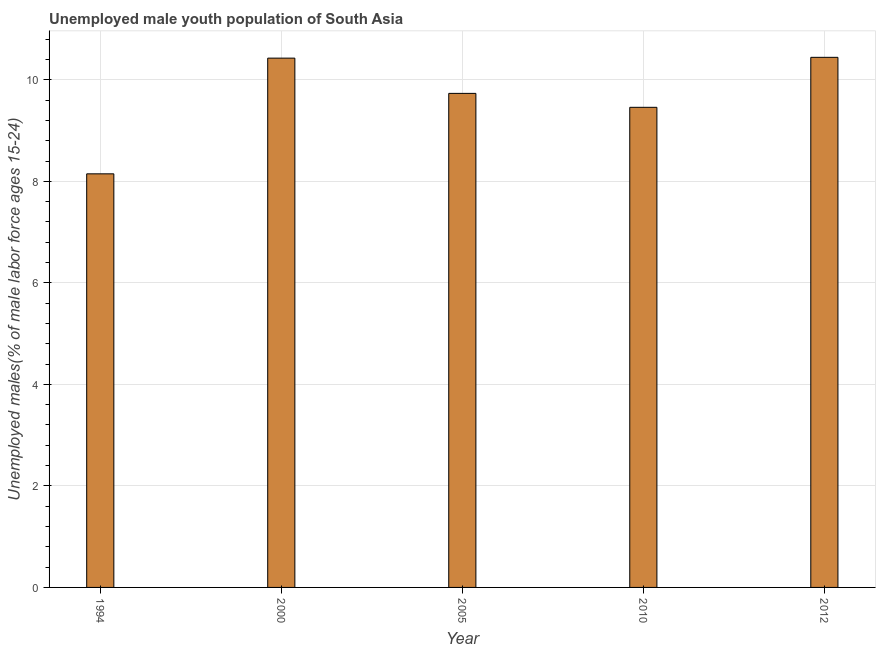Does the graph contain any zero values?
Your answer should be very brief. No. What is the title of the graph?
Your answer should be compact. Unemployed male youth population of South Asia. What is the label or title of the X-axis?
Your answer should be very brief. Year. What is the label or title of the Y-axis?
Your response must be concise. Unemployed males(% of male labor force ages 15-24). What is the unemployed male youth in 2010?
Provide a succinct answer. 9.46. Across all years, what is the maximum unemployed male youth?
Your answer should be compact. 10.44. Across all years, what is the minimum unemployed male youth?
Your answer should be very brief. 8.15. In which year was the unemployed male youth maximum?
Make the answer very short. 2012. In which year was the unemployed male youth minimum?
Ensure brevity in your answer.  1994. What is the sum of the unemployed male youth?
Your answer should be very brief. 48.21. What is the difference between the unemployed male youth in 2005 and 2010?
Make the answer very short. 0.28. What is the average unemployed male youth per year?
Give a very brief answer. 9.64. What is the median unemployed male youth?
Your answer should be very brief. 9.73. In how many years, is the unemployed male youth greater than 8.8 %?
Ensure brevity in your answer.  4. What is the ratio of the unemployed male youth in 1994 to that in 2010?
Your response must be concise. 0.86. Is the unemployed male youth in 1994 less than that in 2000?
Your answer should be compact. Yes. Is the difference between the unemployed male youth in 1994 and 2000 greater than the difference between any two years?
Provide a short and direct response. No. What is the difference between the highest and the second highest unemployed male youth?
Your response must be concise. 0.02. Is the sum of the unemployed male youth in 2000 and 2005 greater than the maximum unemployed male youth across all years?
Provide a short and direct response. Yes. How many bars are there?
Your answer should be compact. 5. Are all the bars in the graph horizontal?
Provide a short and direct response. No. How many years are there in the graph?
Your answer should be very brief. 5. Are the values on the major ticks of Y-axis written in scientific E-notation?
Give a very brief answer. No. What is the Unemployed males(% of male labor force ages 15-24) of 1994?
Give a very brief answer. 8.15. What is the Unemployed males(% of male labor force ages 15-24) of 2000?
Make the answer very short. 10.43. What is the Unemployed males(% of male labor force ages 15-24) of 2005?
Keep it short and to the point. 9.73. What is the Unemployed males(% of male labor force ages 15-24) of 2010?
Keep it short and to the point. 9.46. What is the Unemployed males(% of male labor force ages 15-24) in 2012?
Offer a very short reply. 10.44. What is the difference between the Unemployed males(% of male labor force ages 15-24) in 1994 and 2000?
Provide a short and direct response. -2.28. What is the difference between the Unemployed males(% of male labor force ages 15-24) in 1994 and 2005?
Give a very brief answer. -1.58. What is the difference between the Unemployed males(% of male labor force ages 15-24) in 1994 and 2010?
Make the answer very short. -1.31. What is the difference between the Unemployed males(% of male labor force ages 15-24) in 1994 and 2012?
Offer a terse response. -2.3. What is the difference between the Unemployed males(% of male labor force ages 15-24) in 2000 and 2005?
Your response must be concise. 0.69. What is the difference between the Unemployed males(% of male labor force ages 15-24) in 2000 and 2010?
Keep it short and to the point. 0.97. What is the difference between the Unemployed males(% of male labor force ages 15-24) in 2000 and 2012?
Provide a short and direct response. -0.02. What is the difference between the Unemployed males(% of male labor force ages 15-24) in 2005 and 2010?
Provide a short and direct response. 0.27. What is the difference between the Unemployed males(% of male labor force ages 15-24) in 2005 and 2012?
Ensure brevity in your answer.  -0.71. What is the difference between the Unemployed males(% of male labor force ages 15-24) in 2010 and 2012?
Make the answer very short. -0.98. What is the ratio of the Unemployed males(% of male labor force ages 15-24) in 1994 to that in 2000?
Keep it short and to the point. 0.78. What is the ratio of the Unemployed males(% of male labor force ages 15-24) in 1994 to that in 2005?
Offer a very short reply. 0.84. What is the ratio of the Unemployed males(% of male labor force ages 15-24) in 1994 to that in 2010?
Your answer should be compact. 0.86. What is the ratio of the Unemployed males(% of male labor force ages 15-24) in 1994 to that in 2012?
Provide a short and direct response. 0.78. What is the ratio of the Unemployed males(% of male labor force ages 15-24) in 2000 to that in 2005?
Your response must be concise. 1.07. What is the ratio of the Unemployed males(% of male labor force ages 15-24) in 2000 to that in 2010?
Ensure brevity in your answer.  1.1. What is the ratio of the Unemployed males(% of male labor force ages 15-24) in 2005 to that in 2010?
Offer a very short reply. 1.03. What is the ratio of the Unemployed males(% of male labor force ages 15-24) in 2005 to that in 2012?
Offer a very short reply. 0.93. What is the ratio of the Unemployed males(% of male labor force ages 15-24) in 2010 to that in 2012?
Ensure brevity in your answer.  0.91. 